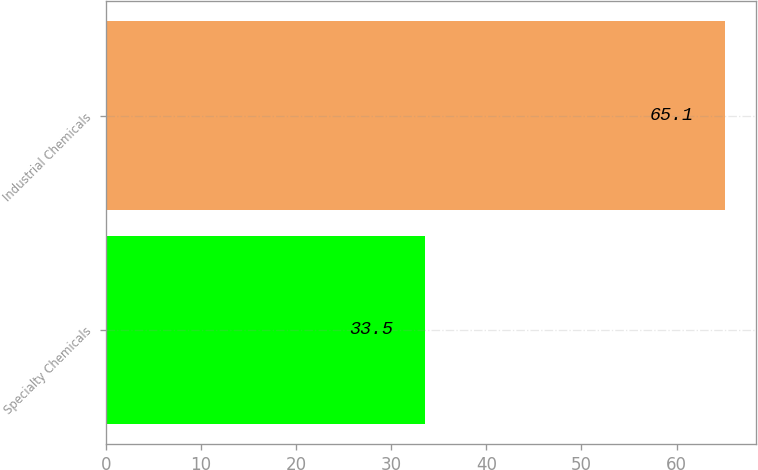Convert chart to OTSL. <chart><loc_0><loc_0><loc_500><loc_500><bar_chart><fcel>Specialty Chemicals<fcel>Industrial Chemicals<nl><fcel>33.5<fcel>65.1<nl></chart> 